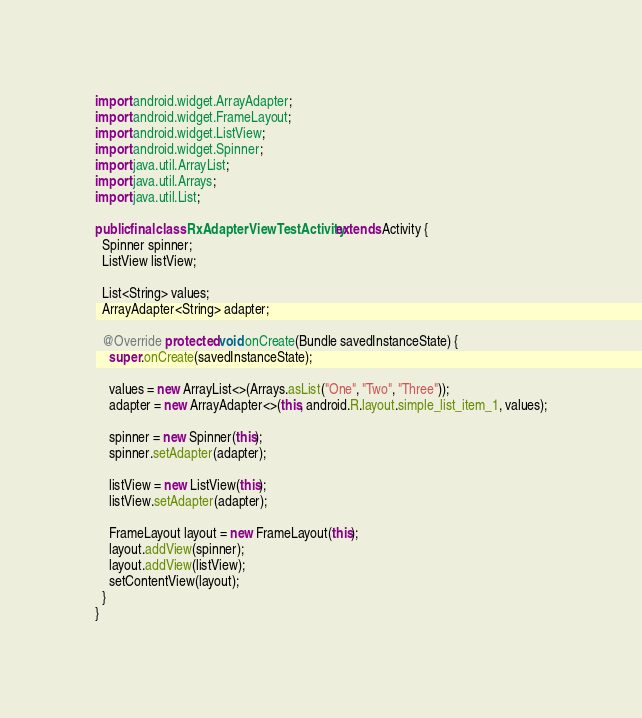<code> <loc_0><loc_0><loc_500><loc_500><_Java_>import android.widget.ArrayAdapter;
import android.widget.FrameLayout;
import android.widget.ListView;
import android.widget.Spinner;
import java.util.ArrayList;
import java.util.Arrays;
import java.util.List;

public final class RxAdapterViewTestActivity extends Activity {
  Spinner spinner;
  ListView listView;

  List<String> values;
  ArrayAdapter<String> adapter;

  @Override protected void onCreate(Bundle savedInstanceState) {
    super.onCreate(savedInstanceState);

    values = new ArrayList<>(Arrays.asList("One", "Two", "Three"));
    adapter = new ArrayAdapter<>(this, android.R.layout.simple_list_item_1, values);

    spinner = new Spinner(this);
    spinner.setAdapter(adapter);

    listView = new ListView(this);
    listView.setAdapter(adapter);

    FrameLayout layout = new FrameLayout(this);
    layout.addView(spinner);
    layout.addView(listView);
    setContentView(layout);
  }
}
</code> 